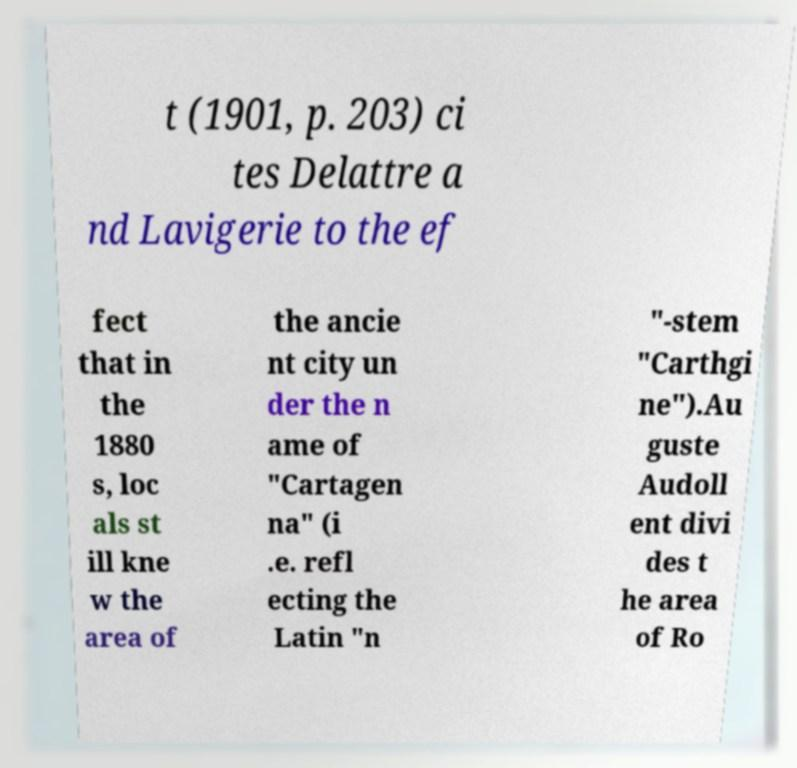Please identify and transcribe the text found in this image. t (1901, p. 203) ci tes Delattre a nd Lavigerie to the ef fect that in the 1880 s, loc als st ill kne w the area of the ancie nt city un der the n ame of "Cartagen na" (i .e. refl ecting the Latin "n "-stem "Carthgi ne").Au guste Audoll ent divi des t he area of Ro 